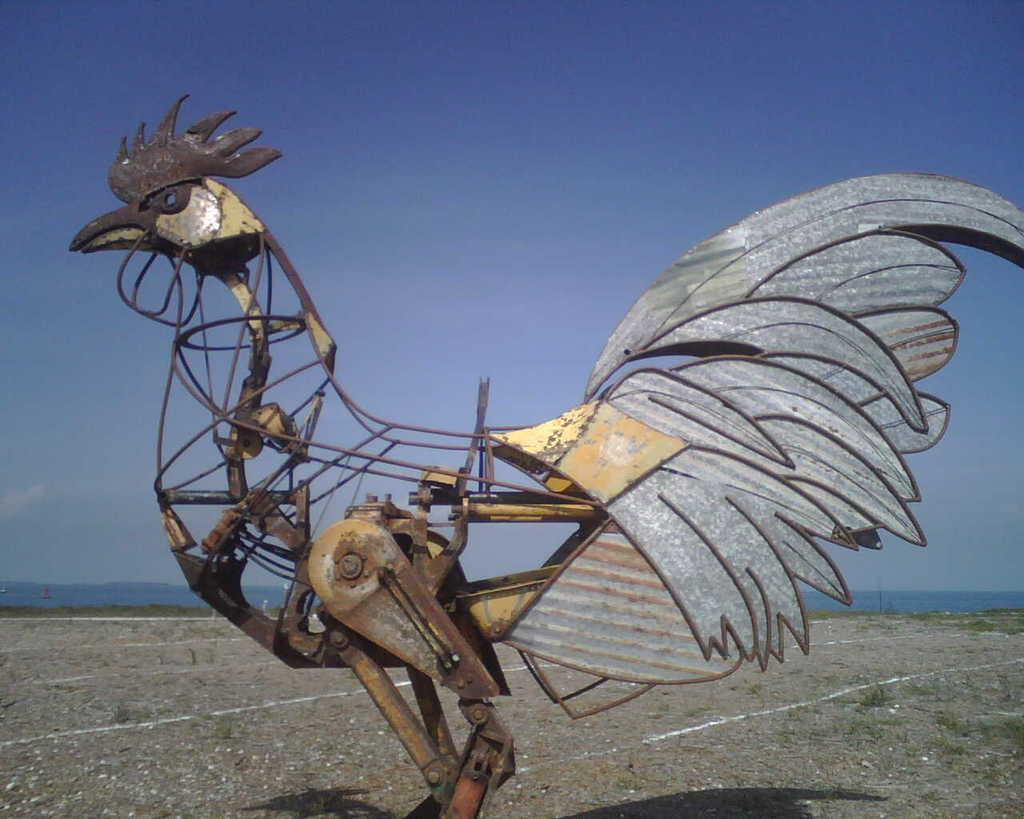What is the main subject of the image made of? The main subject of the image is a hen constructed with metal blocks. What type of natural environment can be seen in the image? There is grass visible in the image, which suggests a natural environment. What is visible in the background of the image? The sky is visible in the image. What type of bag can be seen hanging from the hen's beak in the image? There is no bag present in the image, and the hen's beak is not holding anything. Is there a baseball game taking place in the image? There is no indication of a baseball game or any sports activity in the image. 